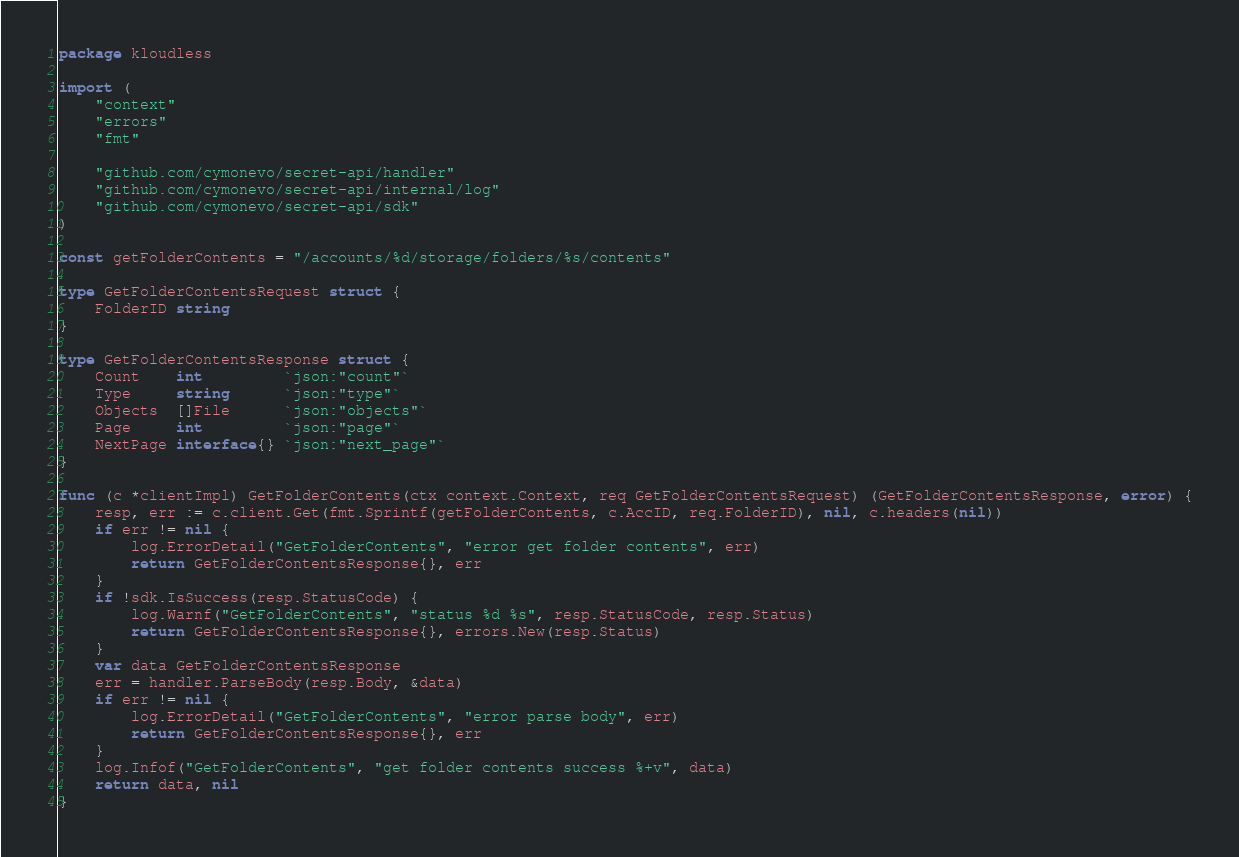Convert code to text. <code><loc_0><loc_0><loc_500><loc_500><_Go_>package kloudless

import (
	"context"
	"errors"
	"fmt"

	"github.com/cymonevo/secret-api/handler"
	"github.com/cymonevo/secret-api/internal/log"
	"github.com/cymonevo/secret-api/sdk"
)

const getFolderContents = "/accounts/%d/storage/folders/%s/contents"

type GetFolderContentsRequest struct {
	FolderID string
}

type GetFolderContentsResponse struct {
	Count    int         `json:"count"`
	Type     string      `json:"type"`
	Objects  []File      `json:"objects"`
	Page     int         `json:"page"`
	NextPage interface{} `json:"next_page"`
}

func (c *clientImpl) GetFolderContents(ctx context.Context, req GetFolderContentsRequest) (GetFolderContentsResponse, error) {
	resp, err := c.client.Get(fmt.Sprintf(getFolderContents, c.AccID, req.FolderID), nil, c.headers(nil))
	if err != nil {
		log.ErrorDetail("GetFolderContents", "error get folder contents", err)
		return GetFolderContentsResponse{}, err
	}
	if !sdk.IsSuccess(resp.StatusCode) {
		log.Warnf("GetFolderContents", "status %d %s", resp.StatusCode, resp.Status)
		return GetFolderContentsResponse{}, errors.New(resp.Status)
	}
	var data GetFolderContentsResponse
	err = handler.ParseBody(resp.Body, &data)
	if err != nil {
		log.ErrorDetail("GetFolderContents", "error parse body", err)
		return GetFolderContentsResponse{}, err
	}
	log.Infof("GetFolderContents", "get folder contents success %+v", data)
	return data, nil
}
</code> 